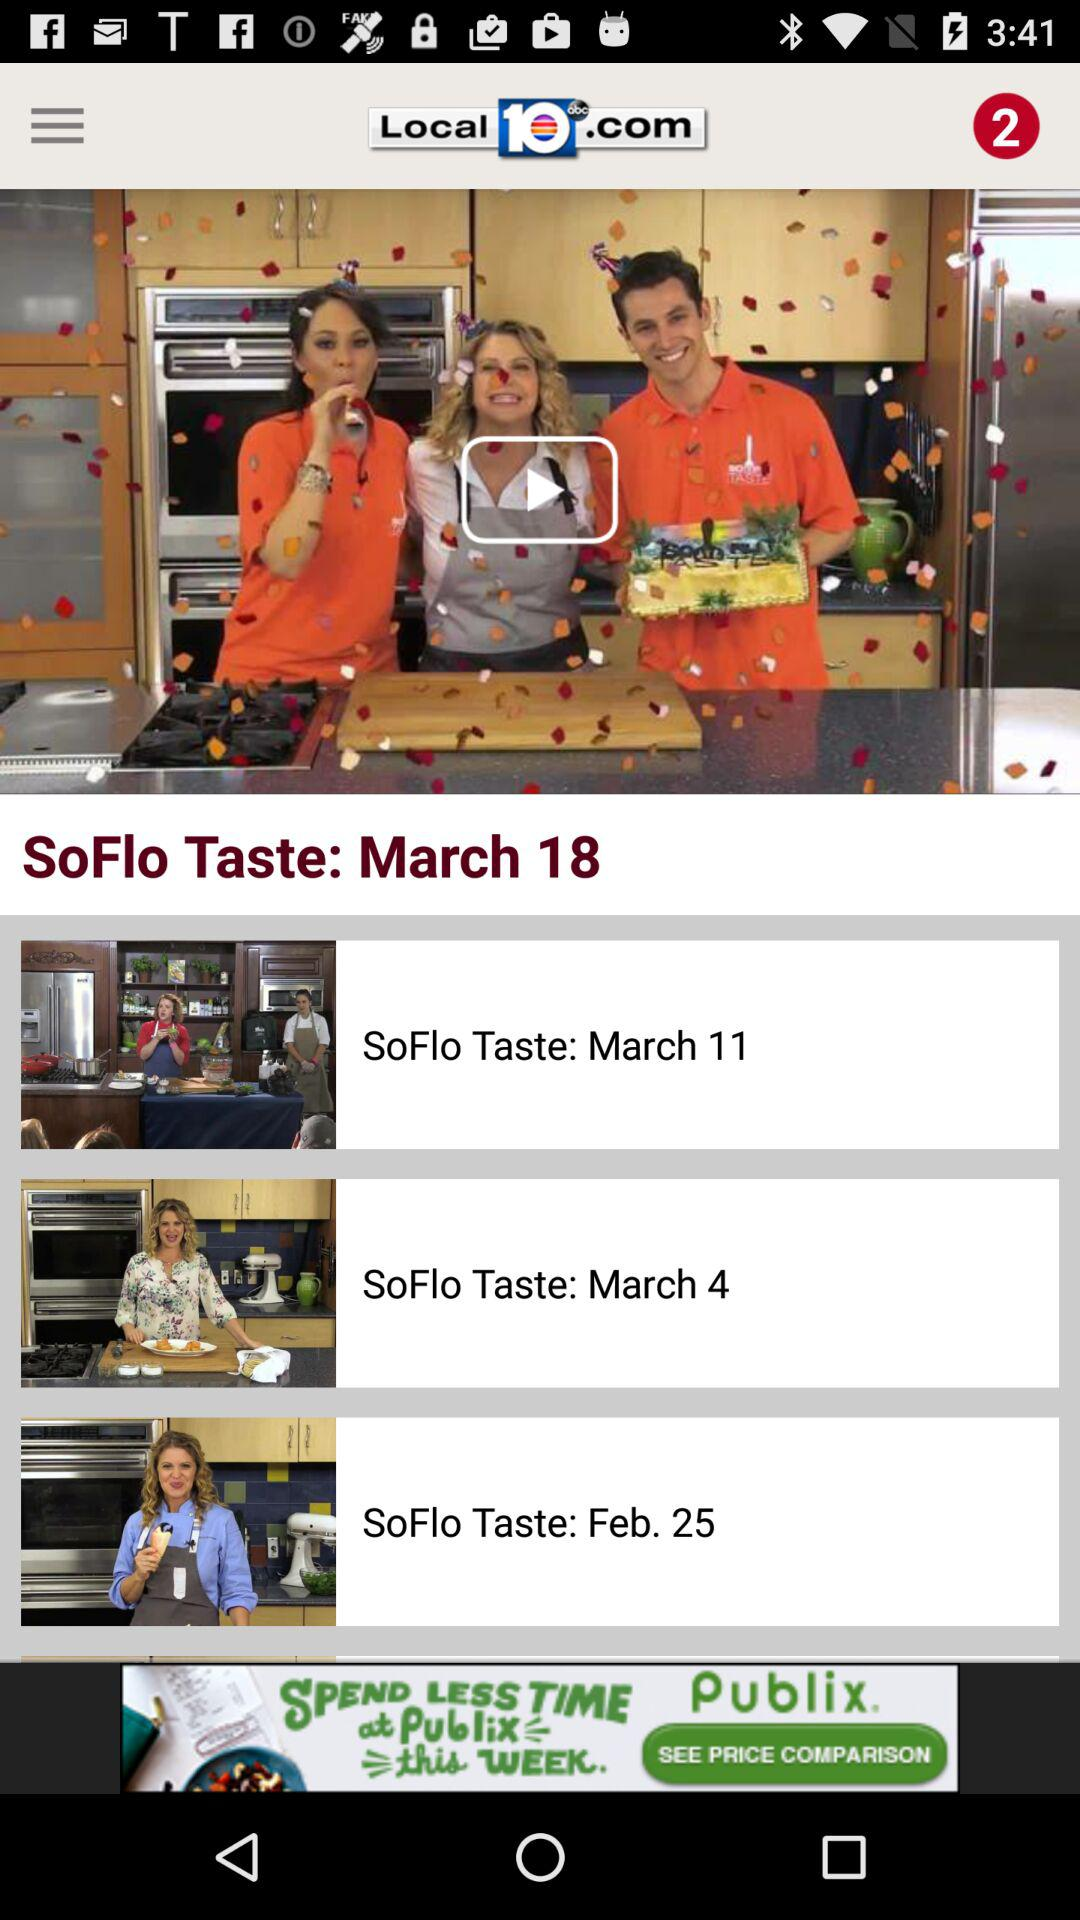What is the current date for "SoFlo taste"? The current date for "SoFlo taste" is March 18. 